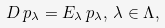<formula> <loc_0><loc_0><loc_500><loc_500>D \, p _ { \lambda } = E _ { \lambda } \, p _ { \lambda } , \, \lambda \in \Lambda ,</formula> 